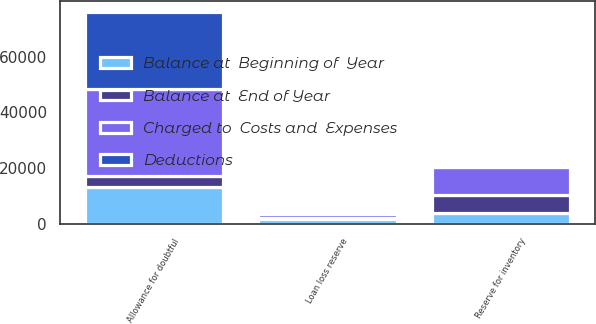<chart> <loc_0><loc_0><loc_500><loc_500><stacked_bar_chart><ecel><fcel>Allowance for doubtful<fcel>Loan loss reserve<fcel>Reserve for inventory<nl><fcel>Balance at  Beginning of  Year<fcel>13109<fcel>1839<fcel>3947<nl><fcel>Balance at  End of Year<fcel>3947<fcel>66<fcel>6357<nl><fcel>Deductions<fcel>27853<fcel>346<fcel>398<nl><fcel>Charged to  Costs and  Expenses<fcel>31241<fcel>1559<fcel>9906<nl></chart> 